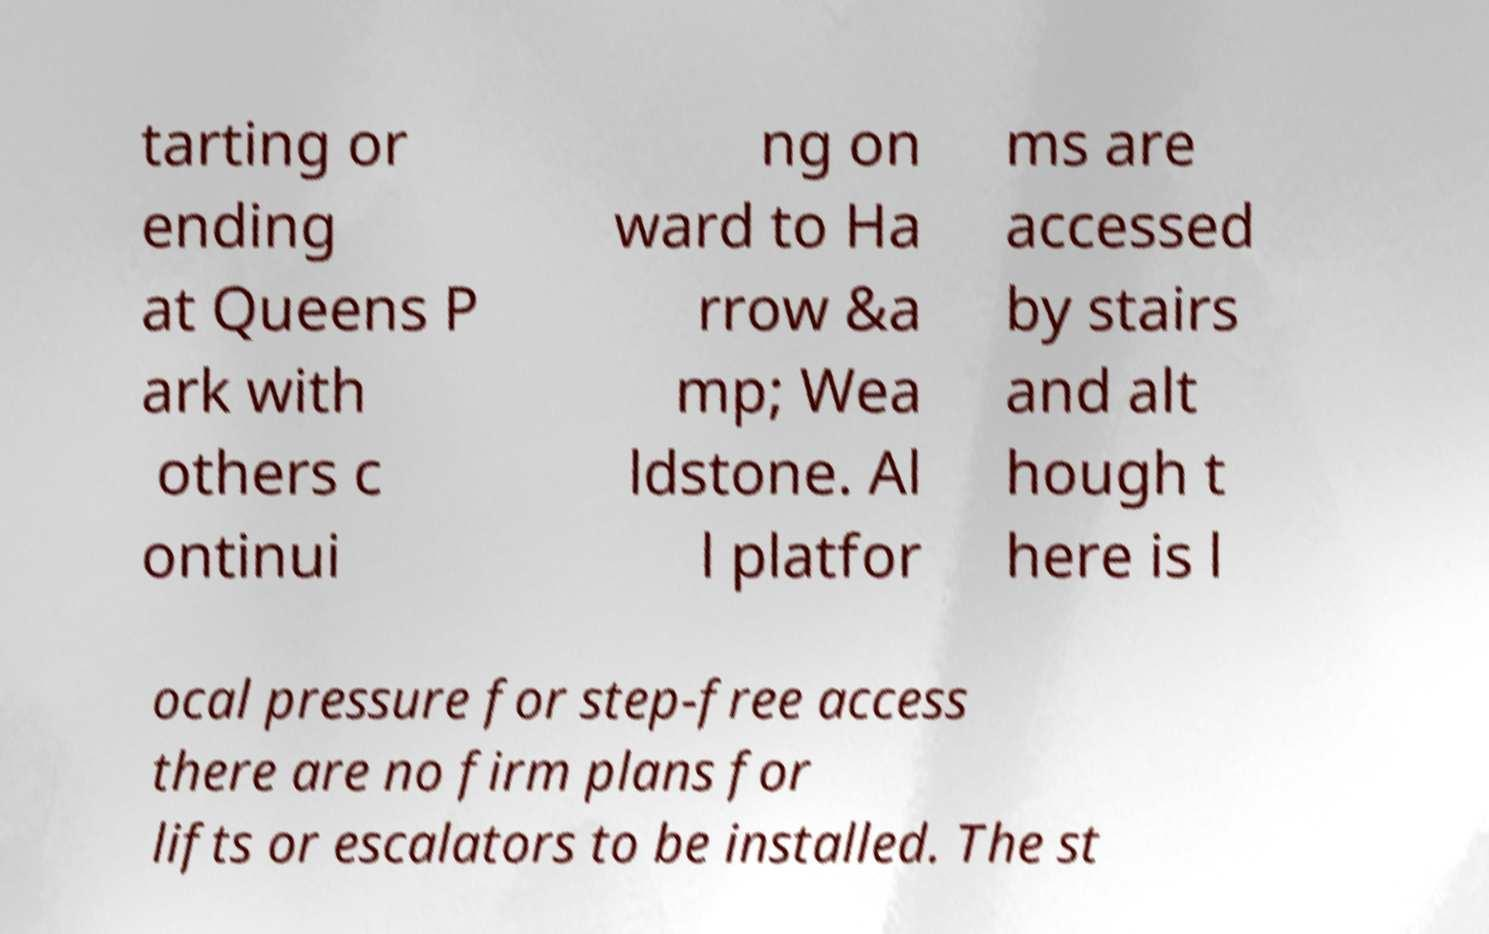What messages or text are displayed in this image? I need them in a readable, typed format. tarting or ending at Queens P ark with others c ontinui ng on ward to Ha rrow &a mp; Wea ldstone. Al l platfor ms are accessed by stairs and alt hough t here is l ocal pressure for step-free access there are no firm plans for lifts or escalators to be installed. The st 